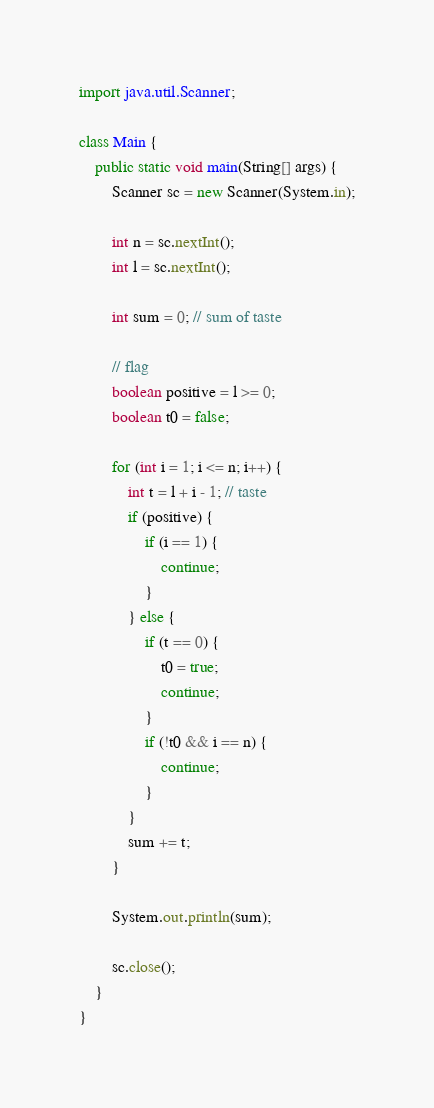Convert code to text. <code><loc_0><loc_0><loc_500><loc_500><_Java_>import java.util.Scanner;

class Main {
	public static void main(String[] args) {
		Scanner sc = new Scanner(System.in);

		int n = sc.nextInt();
		int l = sc.nextInt();

		int sum = 0; // sum of taste

		// flag
		boolean positive = l >= 0;
		boolean t0 = false;

		for (int i = 1; i <= n; i++) {
			int t = l + i - 1; // taste
			if (positive) {
				if (i == 1) {
					continue;
				}
			} else {
				if (t == 0) {
					t0 = true;
					continue;
				}
				if (!t0 && i == n) {
					continue;
				}
			}
			sum += t;
		}

		System.out.println(sum);

		sc.close();
	}
}
</code> 